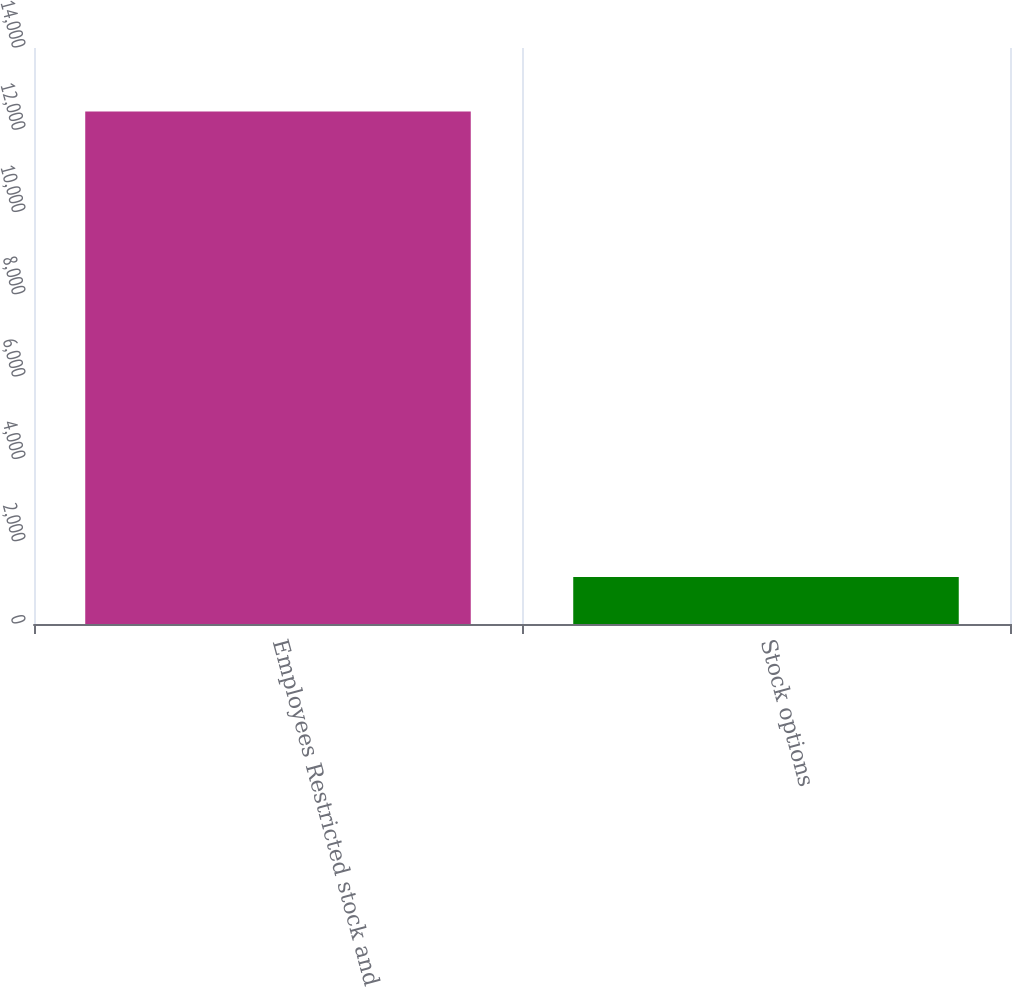<chart> <loc_0><loc_0><loc_500><loc_500><bar_chart><fcel>Employees Restricted stock and<fcel>Stock options<nl><fcel>12459<fcel>1143<nl></chart> 